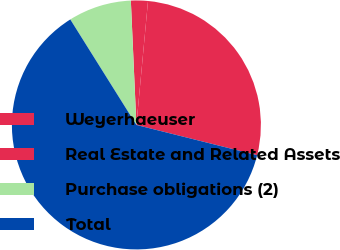Convert chart. <chart><loc_0><loc_0><loc_500><loc_500><pie_chart><fcel>Weyerhaeuser<fcel>Real Estate and Related Assets<fcel>Purchase obligations (2)<fcel>Total<nl><fcel>27.42%<fcel>2.2%<fcel>8.2%<fcel>62.19%<nl></chart> 